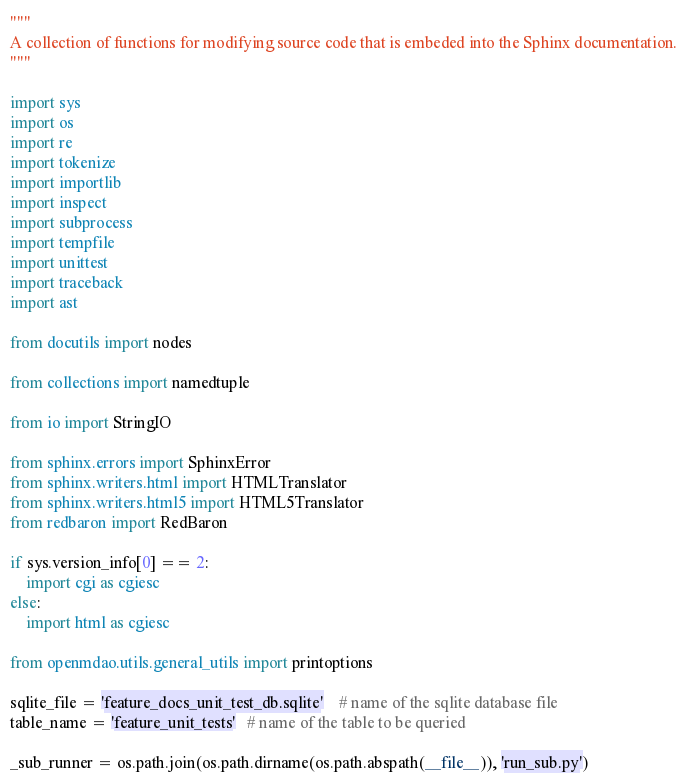Convert code to text. <code><loc_0><loc_0><loc_500><loc_500><_Python_>"""
A collection of functions for modifying source code that is embeded into the Sphinx documentation.
"""

import sys
import os
import re
import tokenize
import importlib
import inspect
import subprocess
import tempfile
import unittest
import traceback
import ast

from docutils import nodes

from collections import namedtuple

from io import StringIO

from sphinx.errors import SphinxError
from sphinx.writers.html import HTMLTranslator
from sphinx.writers.html5 import HTML5Translator
from redbaron import RedBaron

if sys.version_info[0] == 2:
    import cgi as cgiesc
else:
    import html as cgiesc

from openmdao.utils.general_utils import printoptions

sqlite_file = 'feature_docs_unit_test_db.sqlite'    # name of the sqlite database file
table_name = 'feature_unit_tests'   # name of the table to be queried

_sub_runner = os.path.join(os.path.dirname(os.path.abspath(__file__)), 'run_sub.py')

</code> 